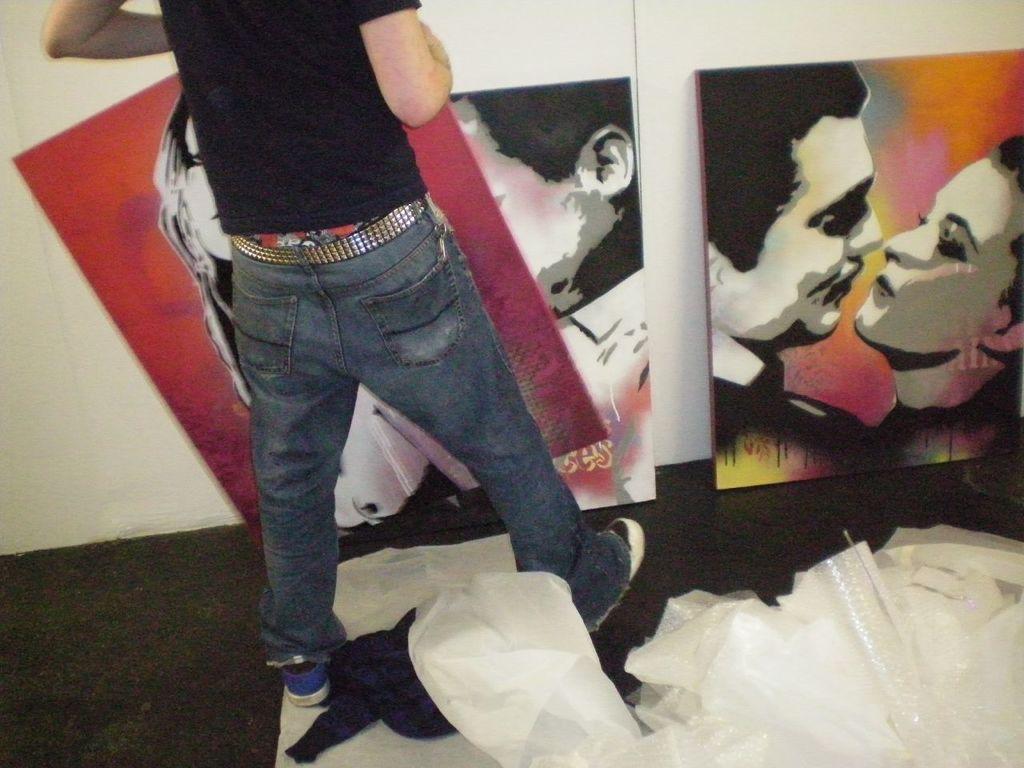How would you summarize this image in a sentence or two? In this picture we can see a person, in front of the person we can find few posters and also we can find few bags. 